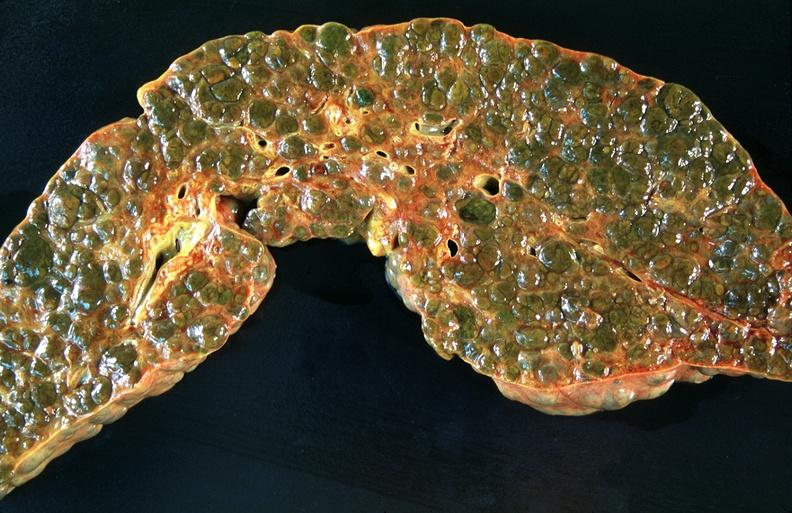does krukenberg tumor show liver, macronodular cirrhosis, hcv?
Answer the question using a single word or phrase. No 